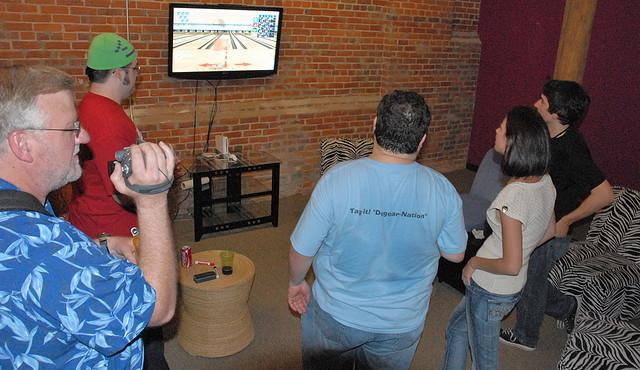Which Wii sport game must be played by the crowd of children in the lounge? Please explain your reasoning. bowling. The game is bowling. 